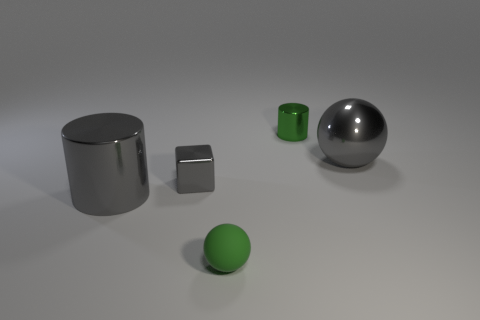Add 5 objects. How many objects exist? 10 Subtract all cubes. How many objects are left? 4 Add 3 tiny green rubber balls. How many tiny green rubber balls are left? 4 Add 5 blue shiny blocks. How many blue shiny blocks exist? 5 Subtract 0 red cylinders. How many objects are left? 5 Subtract all purple spheres. Subtract all cyan cylinders. How many spheres are left? 2 Subtract all big gray cylinders. Subtract all gray metal blocks. How many objects are left? 3 